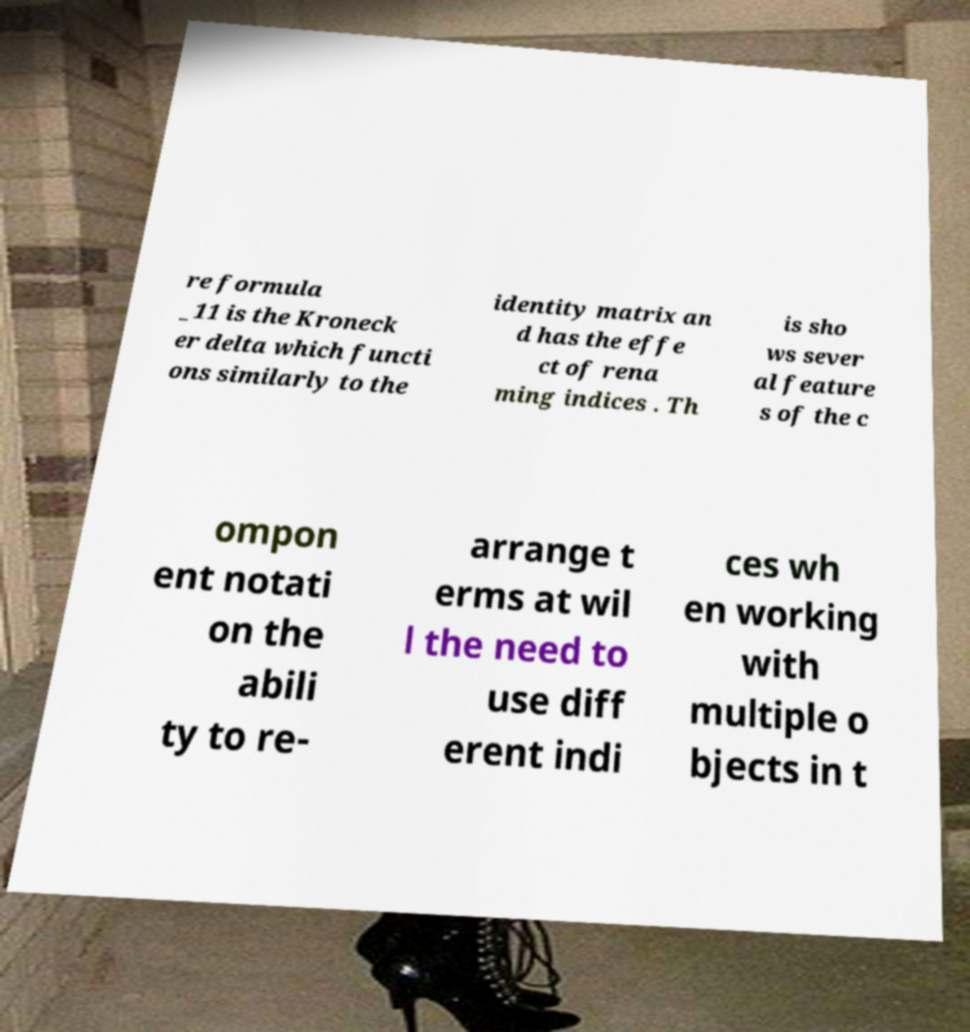For documentation purposes, I need the text within this image transcribed. Could you provide that? re formula _11 is the Kroneck er delta which functi ons similarly to the identity matrix an d has the effe ct of rena ming indices . Th is sho ws sever al feature s of the c ompon ent notati on the abili ty to re- arrange t erms at wil l the need to use diff erent indi ces wh en working with multiple o bjects in t 